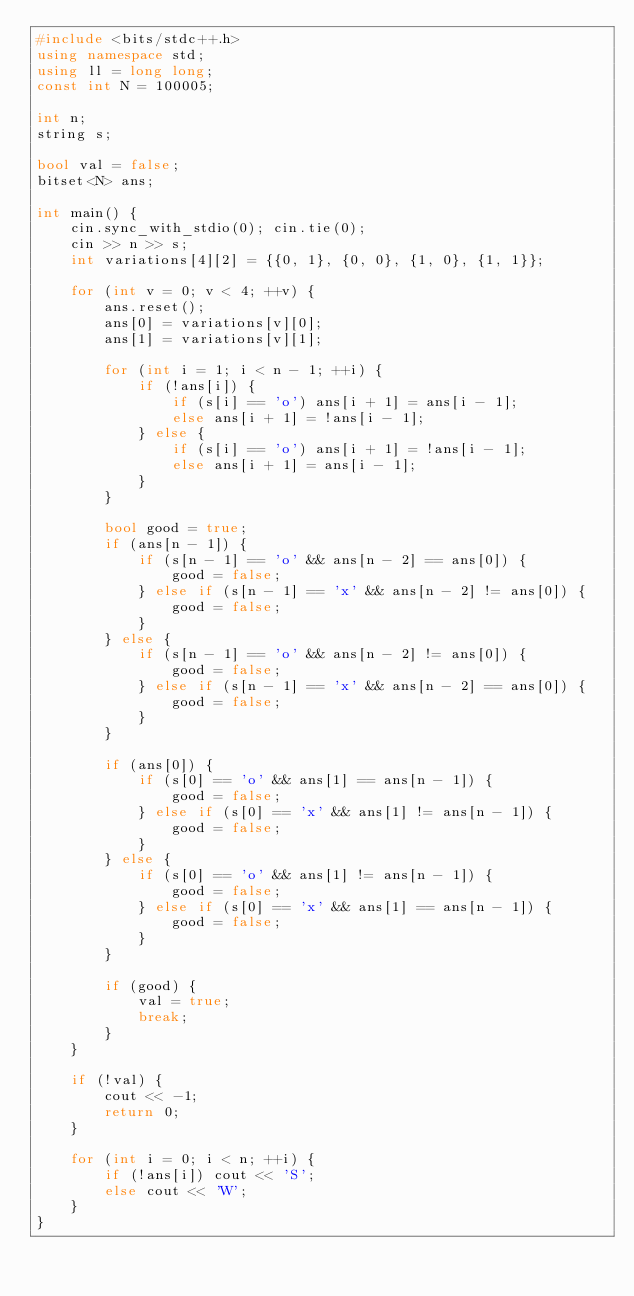<code> <loc_0><loc_0><loc_500><loc_500><_C++_>#include <bits/stdc++.h>
using namespace std;
using ll = long long;
const int N = 100005;

int n;
string s;

bool val = false;
bitset<N> ans;

int main() {
    cin.sync_with_stdio(0); cin.tie(0);
    cin >> n >> s;
    int variations[4][2] = {{0, 1}, {0, 0}, {1, 0}, {1, 1}};

    for (int v = 0; v < 4; ++v) {
        ans.reset();
        ans[0] = variations[v][0];
        ans[1] = variations[v][1];

        for (int i = 1; i < n - 1; ++i) {
            if (!ans[i]) {
                if (s[i] == 'o') ans[i + 1] = ans[i - 1];
                else ans[i + 1] = !ans[i - 1];
            } else {
                if (s[i] == 'o') ans[i + 1] = !ans[i - 1];
                else ans[i + 1] = ans[i - 1];
            }
        }

        bool good = true;
        if (ans[n - 1]) {
            if (s[n - 1] == 'o' && ans[n - 2] == ans[0]) {
                good = false;
            } else if (s[n - 1] == 'x' && ans[n - 2] != ans[0]) {
                good = false;
            }
        } else {
            if (s[n - 1] == 'o' && ans[n - 2] != ans[0]) {
                good = false;
            } else if (s[n - 1] == 'x' && ans[n - 2] == ans[0]) {
                good = false;
            }
        }

        if (ans[0]) {
            if (s[0] == 'o' && ans[1] == ans[n - 1]) {
                good = false;
            } else if (s[0] == 'x' && ans[1] != ans[n - 1]) {
                good = false;
            }
        } else {
            if (s[0] == 'o' && ans[1] != ans[n - 1]) {
                good = false;
            } else if (s[0] == 'x' && ans[1] == ans[n - 1]) {
                good = false;
            }
        }

        if (good) {
            val = true;
            break;
        }
    }

    if (!val) {
        cout << -1;
        return 0;
    }

    for (int i = 0; i < n; ++i) {
        if (!ans[i]) cout << 'S';
        else cout << 'W';
    }
}
</code> 